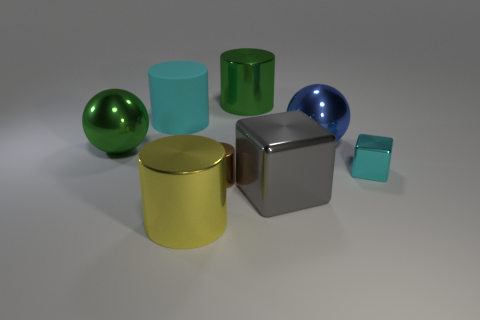Can you describe the difference in textures among the objects shown? Certainly! In the image, we see a variety of textures. The large matte object has a non-reflective, flat finish, while the shiny objects, like the small and large spheres and the cube, have reflective, glossy surfaces that catch the light differently. 